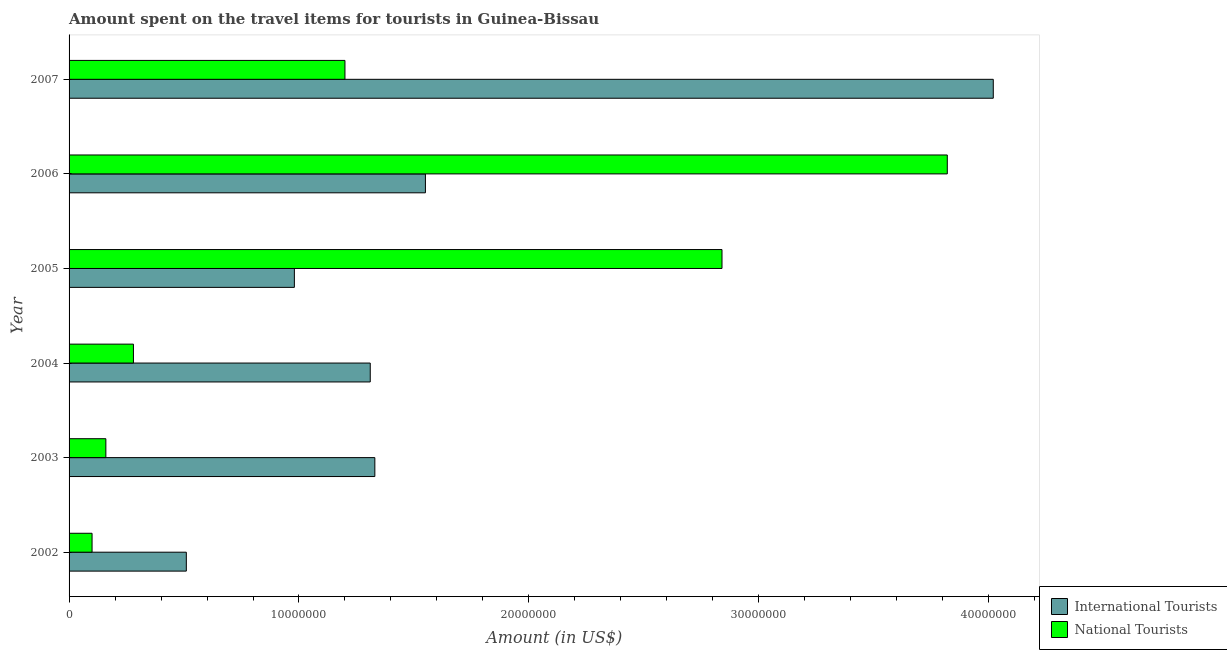How many groups of bars are there?
Keep it short and to the point. 6. Are the number of bars per tick equal to the number of legend labels?
Make the answer very short. Yes. Are the number of bars on each tick of the Y-axis equal?
Make the answer very short. Yes. How many bars are there on the 5th tick from the top?
Ensure brevity in your answer.  2. In how many cases, is the number of bars for a given year not equal to the number of legend labels?
Give a very brief answer. 0. What is the amount spent on travel items of national tourists in 2005?
Your answer should be very brief. 2.84e+07. Across all years, what is the maximum amount spent on travel items of national tourists?
Keep it short and to the point. 3.82e+07. Across all years, what is the minimum amount spent on travel items of international tourists?
Ensure brevity in your answer.  5.10e+06. What is the total amount spent on travel items of international tourists in the graph?
Ensure brevity in your answer.  9.70e+07. What is the difference between the amount spent on travel items of international tourists in 2002 and that in 2005?
Provide a succinct answer. -4.70e+06. What is the difference between the amount spent on travel items of national tourists in 2002 and the amount spent on travel items of international tourists in 2003?
Ensure brevity in your answer.  -1.23e+07. What is the average amount spent on travel items of international tourists per year?
Ensure brevity in your answer.  1.62e+07. In the year 2002, what is the difference between the amount spent on travel items of international tourists and amount spent on travel items of national tourists?
Offer a very short reply. 4.10e+06. In how many years, is the amount spent on travel items of national tourists greater than 34000000 US$?
Offer a terse response. 1. What is the ratio of the amount spent on travel items of national tourists in 2004 to that in 2006?
Your answer should be compact. 0.07. Is the amount spent on travel items of national tourists in 2005 less than that in 2006?
Your answer should be compact. Yes. What is the difference between the highest and the second highest amount spent on travel items of international tourists?
Your answer should be very brief. 2.47e+07. What is the difference between the highest and the lowest amount spent on travel items of international tourists?
Provide a succinct answer. 3.51e+07. In how many years, is the amount spent on travel items of national tourists greater than the average amount spent on travel items of national tourists taken over all years?
Your answer should be very brief. 2. What does the 1st bar from the top in 2003 represents?
Keep it short and to the point. National Tourists. What does the 1st bar from the bottom in 2007 represents?
Make the answer very short. International Tourists. How many legend labels are there?
Your response must be concise. 2. How are the legend labels stacked?
Your answer should be compact. Vertical. What is the title of the graph?
Your answer should be very brief. Amount spent on the travel items for tourists in Guinea-Bissau. Does "Secondary" appear as one of the legend labels in the graph?
Your answer should be compact. No. What is the label or title of the X-axis?
Ensure brevity in your answer.  Amount (in US$). What is the label or title of the Y-axis?
Offer a very short reply. Year. What is the Amount (in US$) in International Tourists in 2002?
Your answer should be very brief. 5.10e+06. What is the Amount (in US$) of International Tourists in 2003?
Make the answer very short. 1.33e+07. What is the Amount (in US$) in National Tourists in 2003?
Give a very brief answer. 1.60e+06. What is the Amount (in US$) of International Tourists in 2004?
Offer a very short reply. 1.31e+07. What is the Amount (in US$) of National Tourists in 2004?
Offer a very short reply. 2.80e+06. What is the Amount (in US$) in International Tourists in 2005?
Offer a very short reply. 9.80e+06. What is the Amount (in US$) of National Tourists in 2005?
Your response must be concise. 2.84e+07. What is the Amount (in US$) of International Tourists in 2006?
Provide a short and direct response. 1.55e+07. What is the Amount (in US$) of National Tourists in 2006?
Provide a short and direct response. 3.82e+07. What is the Amount (in US$) in International Tourists in 2007?
Provide a succinct answer. 4.02e+07. Across all years, what is the maximum Amount (in US$) of International Tourists?
Your response must be concise. 4.02e+07. Across all years, what is the maximum Amount (in US$) in National Tourists?
Keep it short and to the point. 3.82e+07. Across all years, what is the minimum Amount (in US$) in International Tourists?
Give a very brief answer. 5.10e+06. Across all years, what is the minimum Amount (in US$) of National Tourists?
Give a very brief answer. 1.00e+06. What is the total Amount (in US$) in International Tourists in the graph?
Provide a succinct answer. 9.70e+07. What is the total Amount (in US$) of National Tourists in the graph?
Provide a succinct answer. 8.40e+07. What is the difference between the Amount (in US$) in International Tourists in 2002 and that in 2003?
Make the answer very short. -8.20e+06. What is the difference between the Amount (in US$) in National Tourists in 2002 and that in 2003?
Provide a succinct answer. -6.00e+05. What is the difference between the Amount (in US$) in International Tourists in 2002 and that in 2004?
Your answer should be compact. -8.00e+06. What is the difference between the Amount (in US$) of National Tourists in 2002 and that in 2004?
Provide a short and direct response. -1.80e+06. What is the difference between the Amount (in US$) in International Tourists in 2002 and that in 2005?
Offer a very short reply. -4.70e+06. What is the difference between the Amount (in US$) in National Tourists in 2002 and that in 2005?
Give a very brief answer. -2.74e+07. What is the difference between the Amount (in US$) in International Tourists in 2002 and that in 2006?
Your answer should be compact. -1.04e+07. What is the difference between the Amount (in US$) in National Tourists in 2002 and that in 2006?
Your answer should be compact. -3.72e+07. What is the difference between the Amount (in US$) in International Tourists in 2002 and that in 2007?
Your response must be concise. -3.51e+07. What is the difference between the Amount (in US$) of National Tourists in 2002 and that in 2007?
Offer a very short reply. -1.10e+07. What is the difference between the Amount (in US$) in National Tourists in 2003 and that in 2004?
Your response must be concise. -1.20e+06. What is the difference between the Amount (in US$) of International Tourists in 2003 and that in 2005?
Keep it short and to the point. 3.50e+06. What is the difference between the Amount (in US$) of National Tourists in 2003 and that in 2005?
Offer a very short reply. -2.68e+07. What is the difference between the Amount (in US$) in International Tourists in 2003 and that in 2006?
Provide a succinct answer. -2.20e+06. What is the difference between the Amount (in US$) in National Tourists in 2003 and that in 2006?
Ensure brevity in your answer.  -3.66e+07. What is the difference between the Amount (in US$) of International Tourists in 2003 and that in 2007?
Your answer should be very brief. -2.69e+07. What is the difference between the Amount (in US$) of National Tourists in 2003 and that in 2007?
Your answer should be very brief. -1.04e+07. What is the difference between the Amount (in US$) in International Tourists in 2004 and that in 2005?
Give a very brief answer. 3.30e+06. What is the difference between the Amount (in US$) in National Tourists in 2004 and that in 2005?
Ensure brevity in your answer.  -2.56e+07. What is the difference between the Amount (in US$) of International Tourists in 2004 and that in 2006?
Make the answer very short. -2.40e+06. What is the difference between the Amount (in US$) in National Tourists in 2004 and that in 2006?
Give a very brief answer. -3.54e+07. What is the difference between the Amount (in US$) of International Tourists in 2004 and that in 2007?
Your answer should be very brief. -2.71e+07. What is the difference between the Amount (in US$) of National Tourists in 2004 and that in 2007?
Offer a very short reply. -9.20e+06. What is the difference between the Amount (in US$) of International Tourists in 2005 and that in 2006?
Offer a terse response. -5.70e+06. What is the difference between the Amount (in US$) of National Tourists in 2005 and that in 2006?
Your answer should be compact. -9.80e+06. What is the difference between the Amount (in US$) in International Tourists in 2005 and that in 2007?
Provide a short and direct response. -3.04e+07. What is the difference between the Amount (in US$) of National Tourists in 2005 and that in 2007?
Provide a succinct answer. 1.64e+07. What is the difference between the Amount (in US$) in International Tourists in 2006 and that in 2007?
Offer a terse response. -2.47e+07. What is the difference between the Amount (in US$) of National Tourists in 2006 and that in 2007?
Provide a short and direct response. 2.62e+07. What is the difference between the Amount (in US$) of International Tourists in 2002 and the Amount (in US$) of National Tourists in 2003?
Your answer should be very brief. 3.50e+06. What is the difference between the Amount (in US$) of International Tourists in 2002 and the Amount (in US$) of National Tourists in 2004?
Make the answer very short. 2.30e+06. What is the difference between the Amount (in US$) in International Tourists in 2002 and the Amount (in US$) in National Tourists in 2005?
Give a very brief answer. -2.33e+07. What is the difference between the Amount (in US$) in International Tourists in 2002 and the Amount (in US$) in National Tourists in 2006?
Your response must be concise. -3.31e+07. What is the difference between the Amount (in US$) in International Tourists in 2002 and the Amount (in US$) in National Tourists in 2007?
Keep it short and to the point. -6.90e+06. What is the difference between the Amount (in US$) in International Tourists in 2003 and the Amount (in US$) in National Tourists in 2004?
Your response must be concise. 1.05e+07. What is the difference between the Amount (in US$) of International Tourists in 2003 and the Amount (in US$) of National Tourists in 2005?
Your answer should be very brief. -1.51e+07. What is the difference between the Amount (in US$) in International Tourists in 2003 and the Amount (in US$) in National Tourists in 2006?
Your answer should be very brief. -2.49e+07. What is the difference between the Amount (in US$) of International Tourists in 2003 and the Amount (in US$) of National Tourists in 2007?
Keep it short and to the point. 1.30e+06. What is the difference between the Amount (in US$) of International Tourists in 2004 and the Amount (in US$) of National Tourists in 2005?
Provide a short and direct response. -1.53e+07. What is the difference between the Amount (in US$) of International Tourists in 2004 and the Amount (in US$) of National Tourists in 2006?
Give a very brief answer. -2.51e+07. What is the difference between the Amount (in US$) of International Tourists in 2004 and the Amount (in US$) of National Tourists in 2007?
Provide a short and direct response. 1.10e+06. What is the difference between the Amount (in US$) of International Tourists in 2005 and the Amount (in US$) of National Tourists in 2006?
Give a very brief answer. -2.84e+07. What is the difference between the Amount (in US$) of International Tourists in 2005 and the Amount (in US$) of National Tourists in 2007?
Provide a short and direct response. -2.20e+06. What is the difference between the Amount (in US$) in International Tourists in 2006 and the Amount (in US$) in National Tourists in 2007?
Offer a very short reply. 3.50e+06. What is the average Amount (in US$) in International Tourists per year?
Your answer should be very brief. 1.62e+07. What is the average Amount (in US$) in National Tourists per year?
Provide a succinct answer. 1.40e+07. In the year 2002, what is the difference between the Amount (in US$) of International Tourists and Amount (in US$) of National Tourists?
Give a very brief answer. 4.10e+06. In the year 2003, what is the difference between the Amount (in US$) in International Tourists and Amount (in US$) in National Tourists?
Keep it short and to the point. 1.17e+07. In the year 2004, what is the difference between the Amount (in US$) in International Tourists and Amount (in US$) in National Tourists?
Provide a succinct answer. 1.03e+07. In the year 2005, what is the difference between the Amount (in US$) of International Tourists and Amount (in US$) of National Tourists?
Make the answer very short. -1.86e+07. In the year 2006, what is the difference between the Amount (in US$) in International Tourists and Amount (in US$) in National Tourists?
Offer a very short reply. -2.27e+07. In the year 2007, what is the difference between the Amount (in US$) of International Tourists and Amount (in US$) of National Tourists?
Keep it short and to the point. 2.82e+07. What is the ratio of the Amount (in US$) of International Tourists in 2002 to that in 2003?
Offer a terse response. 0.38. What is the ratio of the Amount (in US$) in International Tourists in 2002 to that in 2004?
Provide a succinct answer. 0.39. What is the ratio of the Amount (in US$) in National Tourists in 2002 to that in 2004?
Provide a succinct answer. 0.36. What is the ratio of the Amount (in US$) of International Tourists in 2002 to that in 2005?
Offer a very short reply. 0.52. What is the ratio of the Amount (in US$) in National Tourists in 2002 to that in 2005?
Keep it short and to the point. 0.04. What is the ratio of the Amount (in US$) of International Tourists in 2002 to that in 2006?
Offer a terse response. 0.33. What is the ratio of the Amount (in US$) of National Tourists in 2002 to that in 2006?
Make the answer very short. 0.03. What is the ratio of the Amount (in US$) in International Tourists in 2002 to that in 2007?
Your answer should be compact. 0.13. What is the ratio of the Amount (in US$) in National Tourists in 2002 to that in 2007?
Your answer should be very brief. 0.08. What is the ratio of the Amount (in US$) of International Tourists in 2003 to that in 2004?
Your answer should be compact. 1.02. What is the ratio of the Amount (in US$) of International Tourists in 2003 to that in 2005?
Give a very brief answer. 1.36. What is the ratio of the Amount (in US$) in National Tourists in 2003 to that in 2005?
Your response must be concise. 0.06. What is the ratio of the Amount (in US$) in International Tourists in 2003 to that in 2006?
Provide a succinct answer. 0.86. What is the ratio of the Amount (in US$) in National Tourists in 2003 to that in 2006?
Give a very brief answer. 0.04. What is the ratio of the Amount (in US$) of International Tourists in 2003 to that in 2007?
Your answer should be very brief. 0.33. What is the ratio of the Amount (in US$) of National Tourists in 2003 to that in 2007?
Offer a terse response. 0.13. What is the ratio of the Amount (in US$) of International Tourists in 2004 to that in 2005?
Offer a very short reply. 1.34. What is the ratio of the Amount (in US$) of National Tourists in 2004 to that in 2005?
Offer a very short reply. 0.1. What is the ratio of the Amount (in US$) of International Tourists in 2004 to that in 2006?
Keep it short and to the point. 0.85. What is the ratio of the Amount (in US$) of National Tourists in 2004 to that in 2006?
Provide a short and direct response. 0.07. What is the ratio of the Amount (in US$) of International Tourists in 2004 to that in 2007?
Your answer should be compact. 0.33. What is the ratio of the Amount (in US$) of National Tourists in 2004 to that in 2007?
Ensure brevity in your answer.  0.23. What is the ratio of the Amount (in US$) in International Tourists in 2005 to that in 2006?
Your answer should be compact. 0.63. What is the ratio of the Amount (in US$) in National Tourists in 2005 to that in 2006?
Your answer should be compact. 0.74. What is the ratio of the Amount (in US$) of International Tourists in 2005 to that in 2007?
Offer a terse response. 0.24. What is the ratio of the Amount (in US$) of National Tourists in 2005 to that in 2007?
Offer a very short reply. 2.37. What is the ratio of the Amount (in US$) in International Tourists in 2006 to that in 2007?
Provide a short and direct response. 0.39. What is the ratio of the Amount (in US$) of National Tourists in 2006 to that in 2007?
Provide a succinct answer. 3.18. What is the difference between the highest and the second highest Amount (in US$) in International Tourists?
Your answer should be compact. 2.47e+07. What is the difference between the highest and the second highest Amount (in US$) of National Tourists?
Provide a short and direct response. 9.80e+06. What is the difference between the highest and the lowest Amount (in US$) in International Tourists?
Make the answer very short. 3.51e+07. What is the difference between the highest and the lowest Amount (in US$) of National Tourists?
Give a very brief answer. 3.72e+07. 